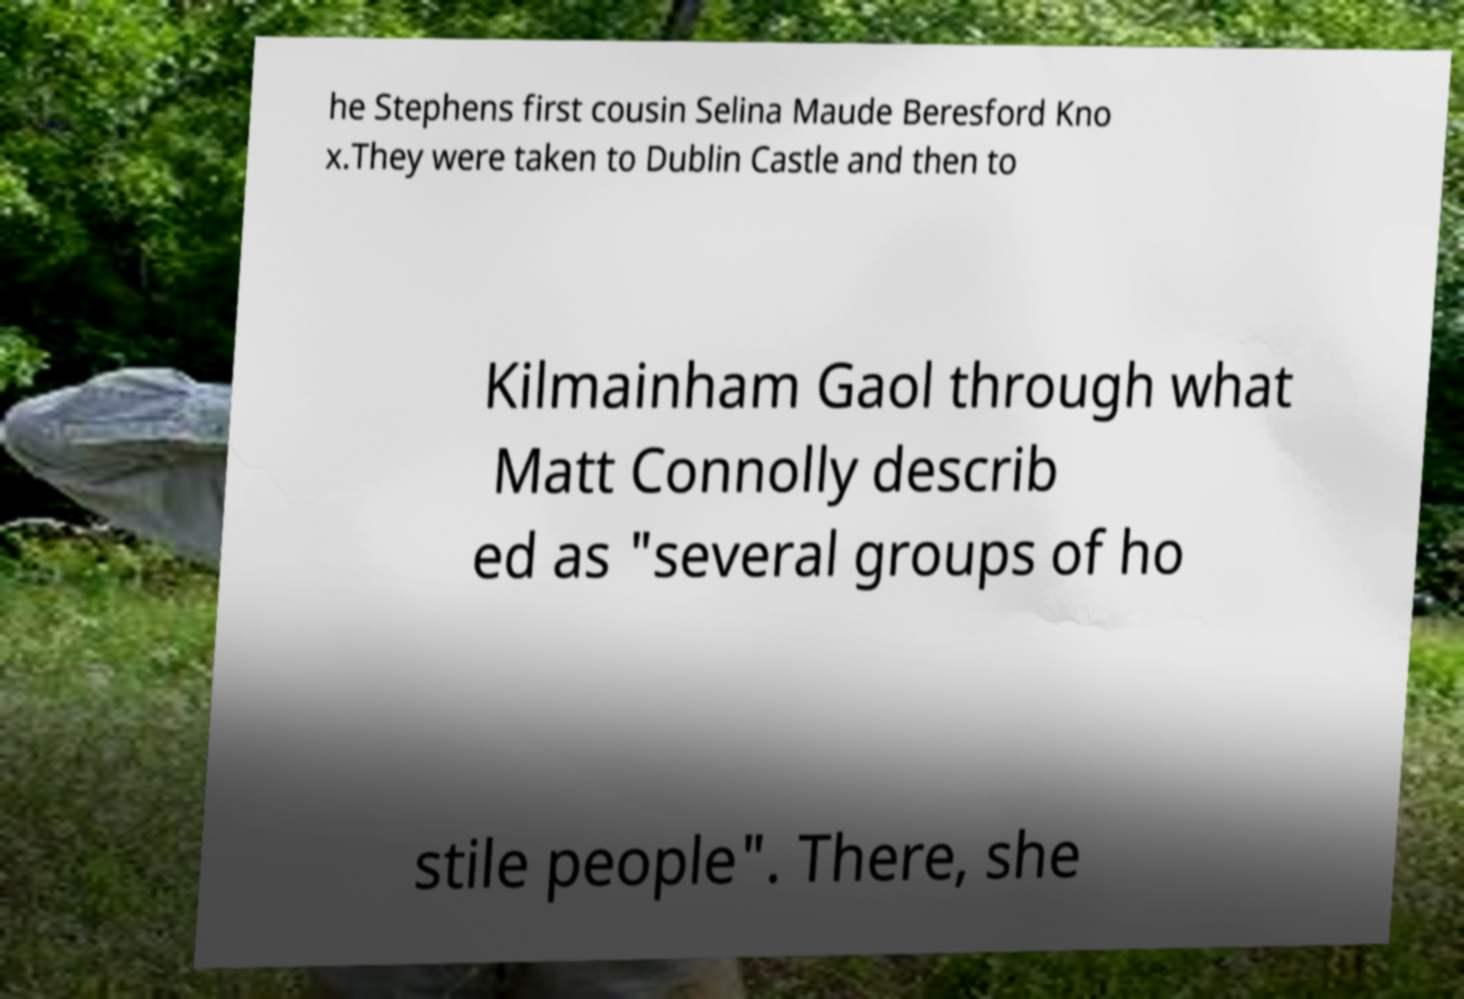Please read and relay the text visible in this image. What does it say? he Stephens first cousin Selina Maude Beresford Kno x.They were taken to Dublin Castle and then to Kilmainham Gaol through what Matt Connolly describ ed as "several groups of ho stile people". There, she 